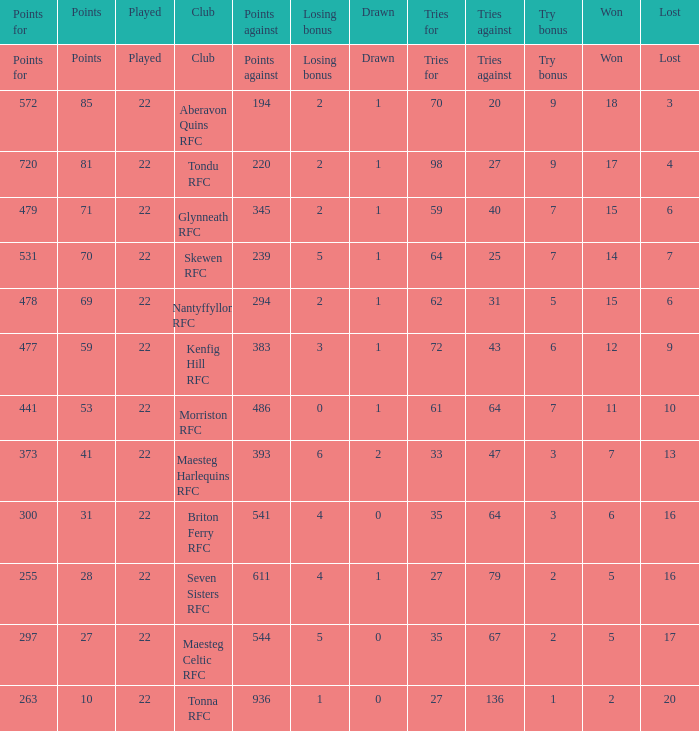Could you help me parse every detail presented in this table? {'header': ['Points for', 'Points', 'Played', 'Club', 'Points against', 'Losing bonus', 'Drawn', 'Tries for', 'Tries against', 'Try bonus', 'Won', 'Lost'], 'rows': [['Points for', 'Points', 'Played', 'Club', 'Points against', 'Losing bonus', 'Drawn', 'Tries for', 'Tries against', 'Try bonus', 'Won', 'Lost'], ['572', '85', '22', 'Aberavon Quins RFC', '194', '2', '1', '70', '20', '9', '18', '3'], ['720', '81', '22', 'Tondu RFC', '220', '2', '1', '98', '27', '9', '17', '4'], ['479', '71', '22', 'Glynneath RFC', '345', '2', '1', '59', '40', '7', '15', '6'], ['531', '70', '22', 'Skewen RFC', '239', '5', '1', '64', '25', '7', '14', '7'], ['478', '69', '22', 'Nantyffyllon RFC', '294', '2', '1', '62', '31', '5', '15', '6'], ['477', '59', '22', 'Kenfig Hill RFC', '383', '3', '1', '72', '43', '6', '12', '9'], ['441', '53', '22', 'Morriston RFC', '486', '0', '1', '61', '64', '7', '11', '10'], ['373', '41', '22', 'Maesteg Harlequins RFC', '393', '6', '2', '33', '47', '3', '7', '13'], ['300', '31', '22', 'Briton Ferry RFC', '541', '4', '0', '35', '64', '3', '6', '16'], ['255', '28', '22', 'Seven Sisters RFC', '611', '4', '1', '27', '79', '2', '5', '16'], ['297', '27', '22', 'Maesteg Celtic RFC', '544', '5', '0', '35', '67', '2', '5', '17'], ['263', '10', '22', 'Tonna RFC', '936', '1', '0', '27', '136', '1', '2', '20']]} What is the value of the points column when the value of the column lost is "lost" Points. 